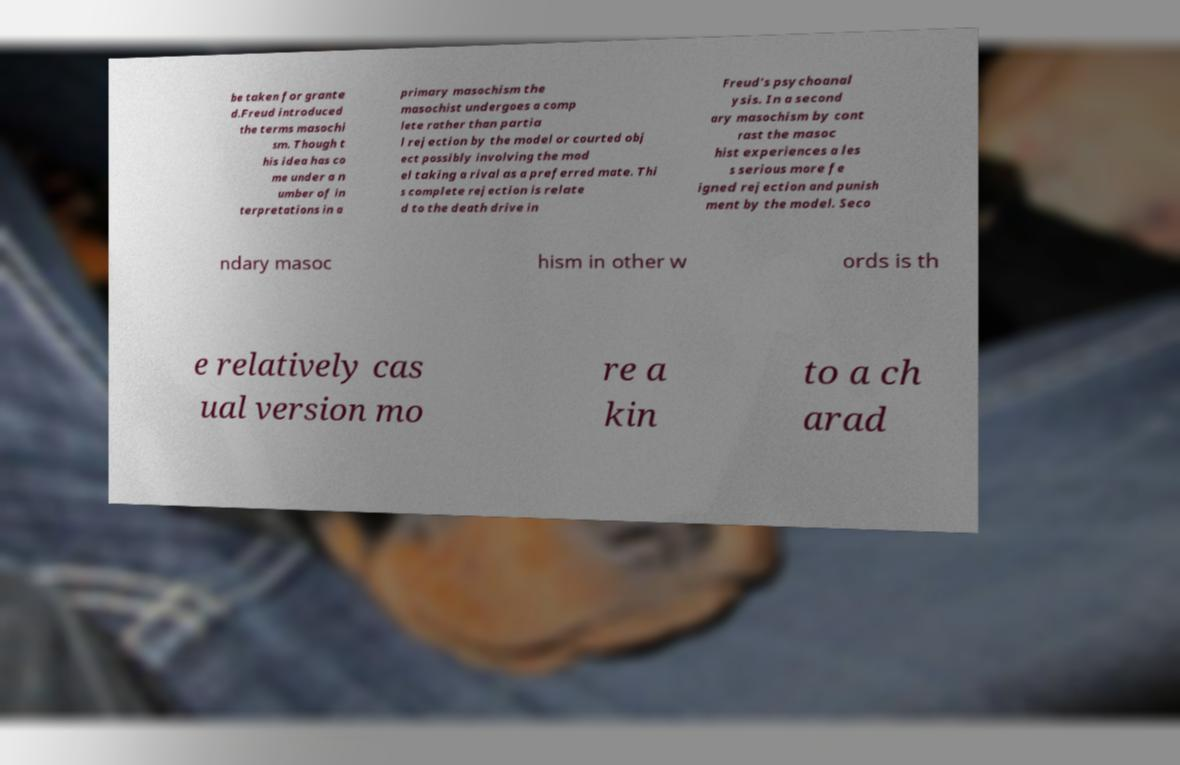Can you read and provide the text displayed in the image?This photo seems to have some interesting text. Can you extract and type it out for me? be taken for grante d.Freud introduced the terms masochi sm. Though t his idea has co me under a n umber of in terpretations in a primary masochism the masochist undergoes a comp lete rather than partia l rejection by the model or courted obj ect possibly involving the mod el taking a rival as a preferred mate. Thi s complete rejection is relate d to the death drive in Freud's psychoanal ysis. In a second ary masochism by cont rast the masoc hist experiences a les s serious more fe igned rejection and punish ment by the model. Seco ndary masoc hism in other w ords is th e relatively cas ual version mo re a kin to a ch arad 